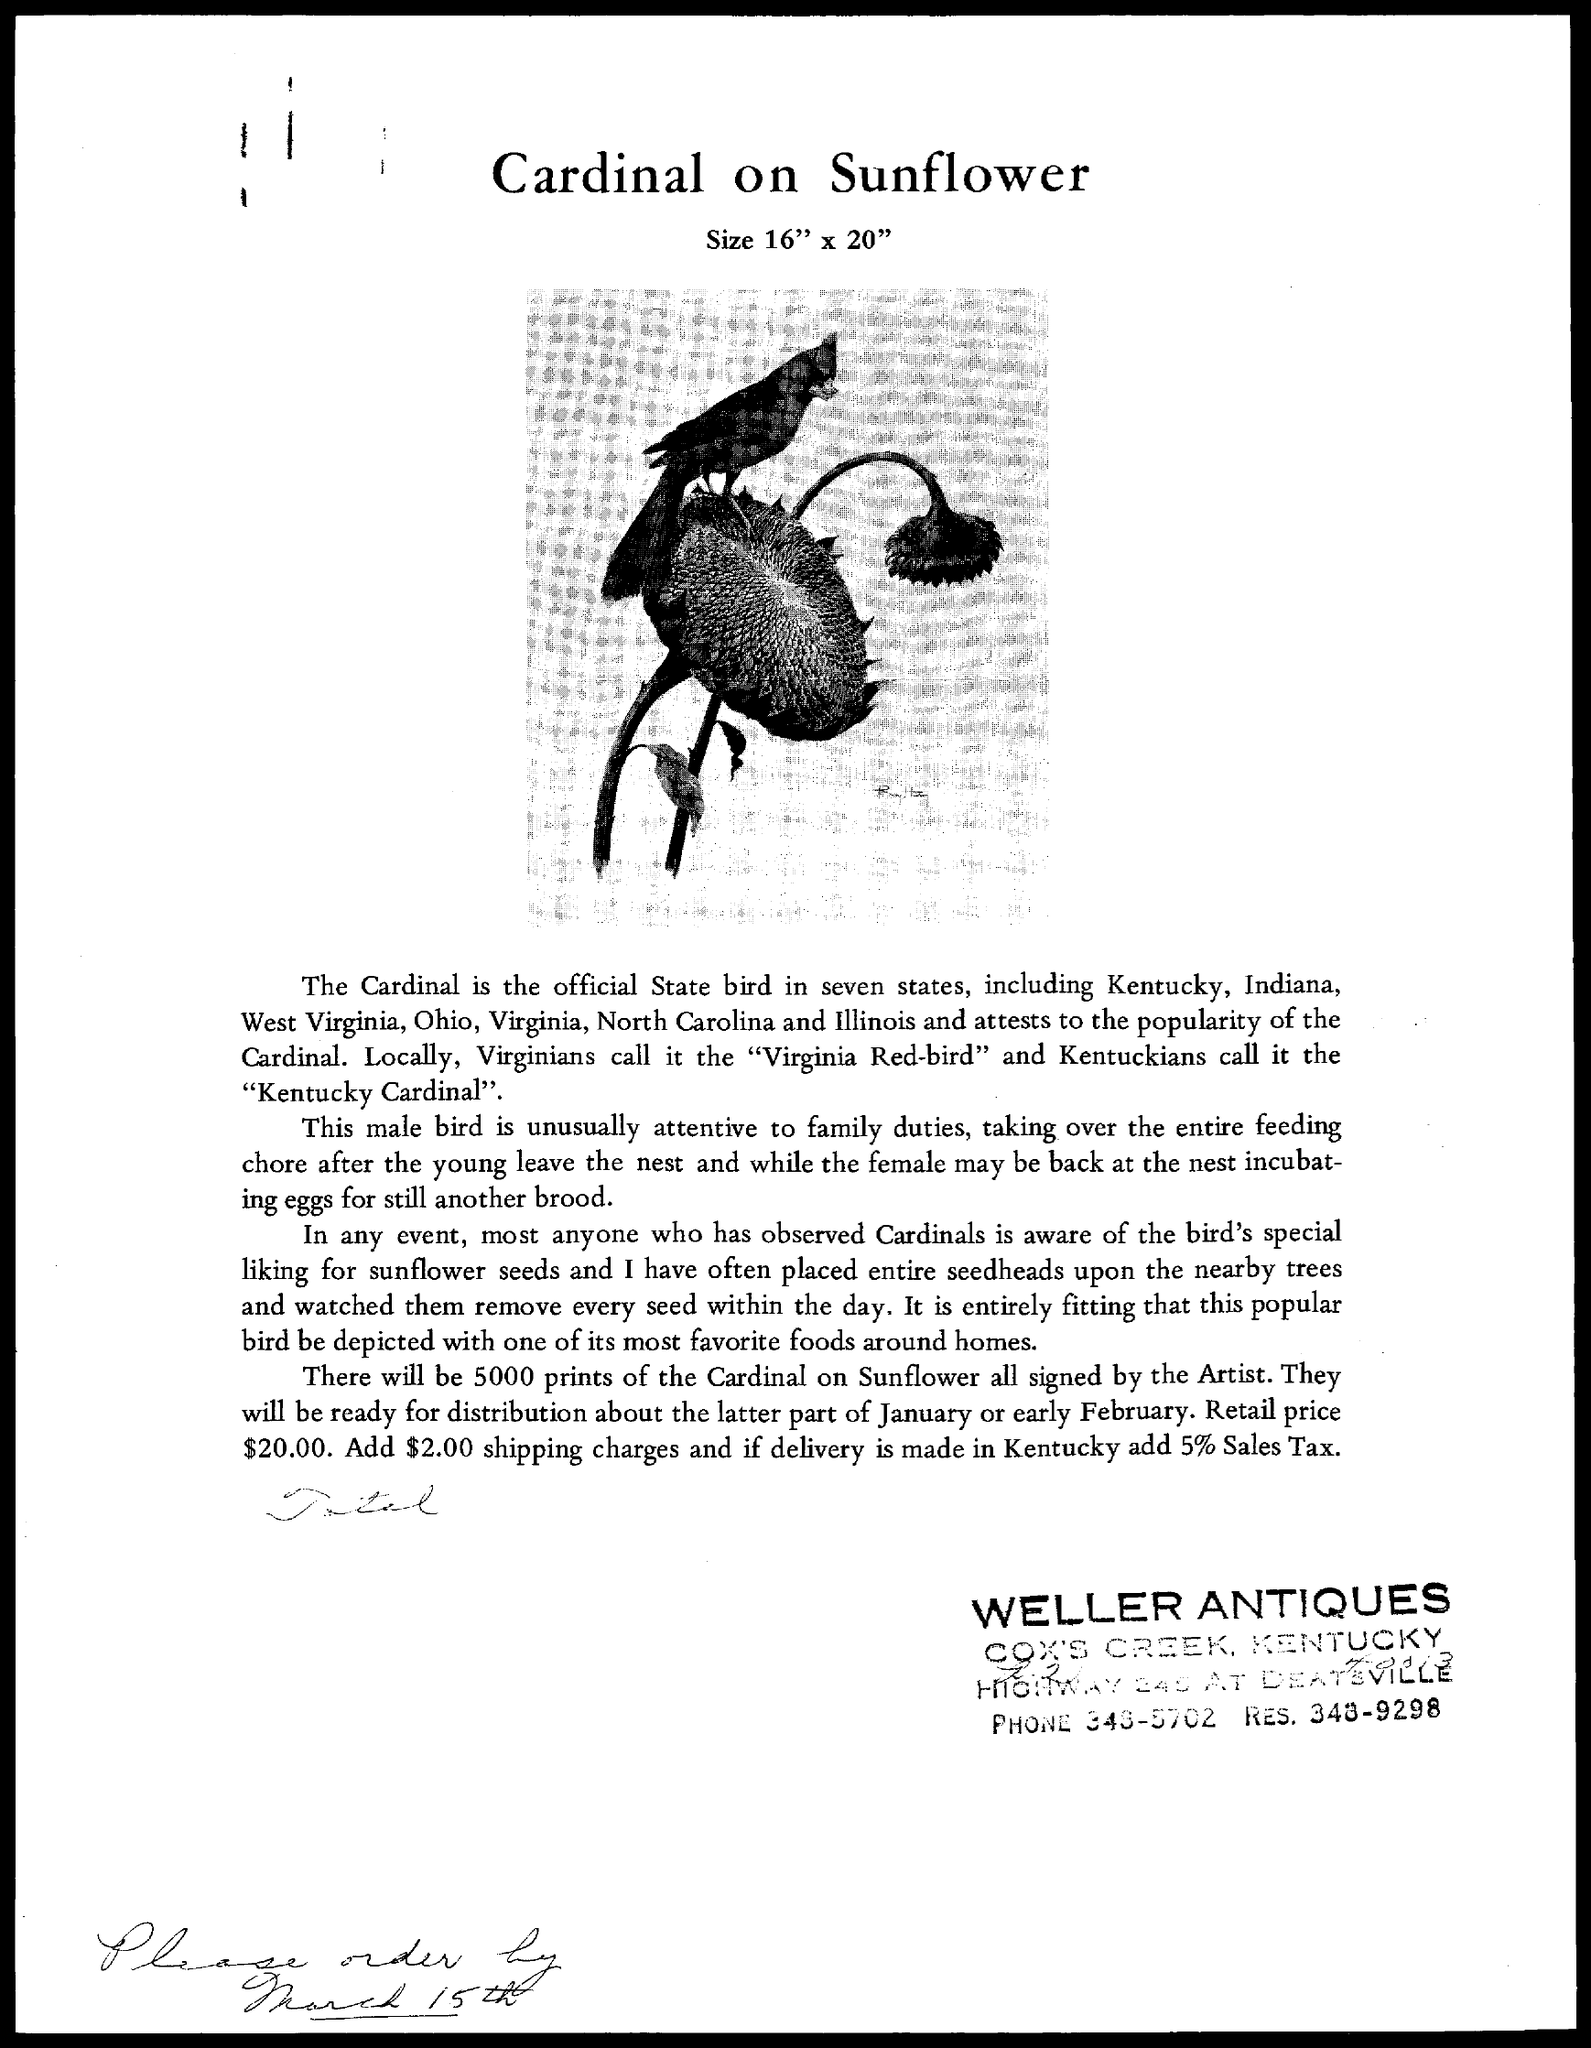What is the title of the document ?
Your answer should be very brief. Cardinal on Sunflower. 